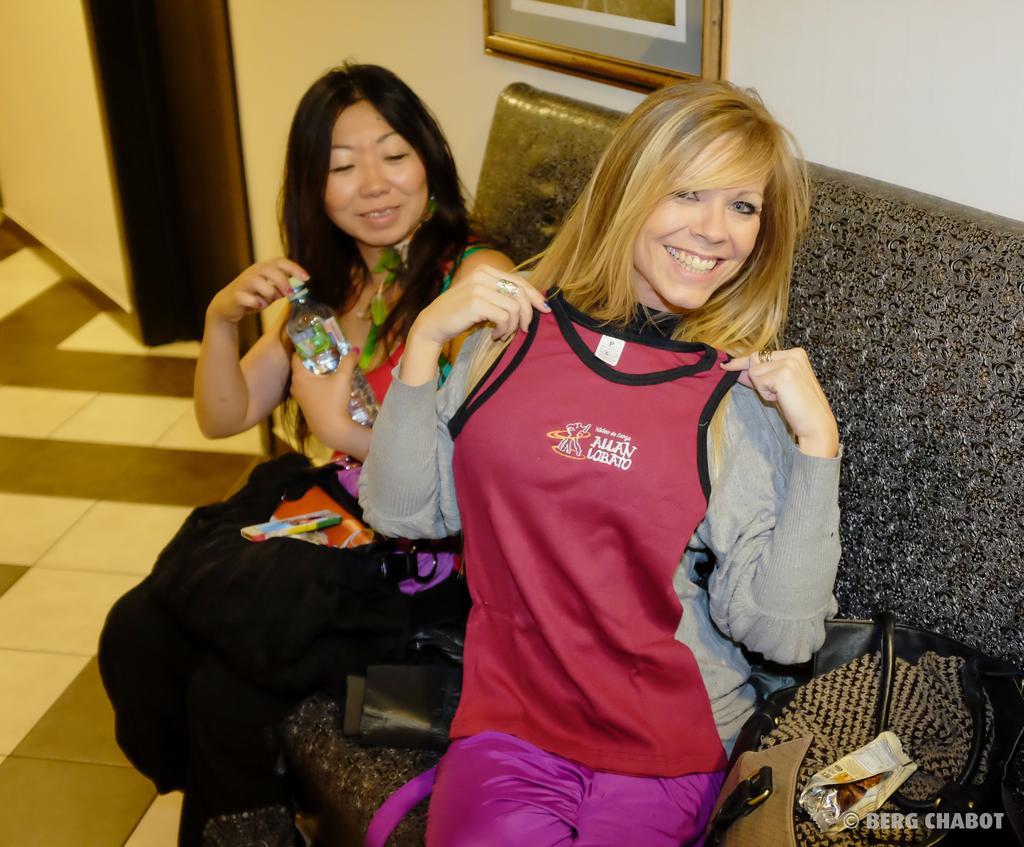Can you describe this image briefly? In this image, I can see two women sitting and smiling. At the bottom right side of the image, I can see a bag on the couch. At the top of the image, It looks like a photo frame, which is attached to a wall. On the left side of the image, I can see the floor. At the bottom right corner of the image, that looks like the watermark. 